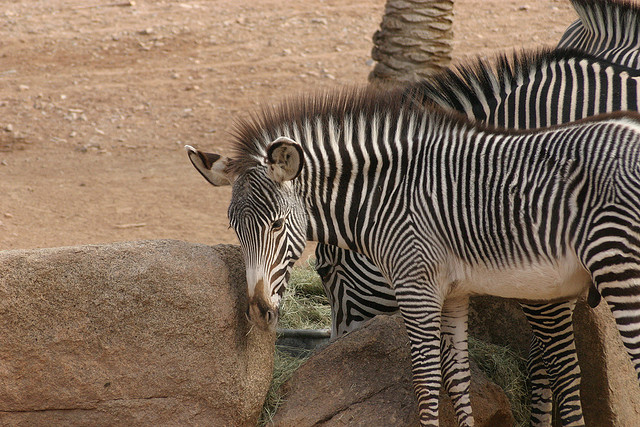<image>Where is the zebra? It is unknown where the zebra is. It could be at a zoo or in the wild. Where is the zebra? I don't know where the zebra is. It can be seen in the zoo, next to a boulder, outside, in front of a rock, or possibly in the jungle. 